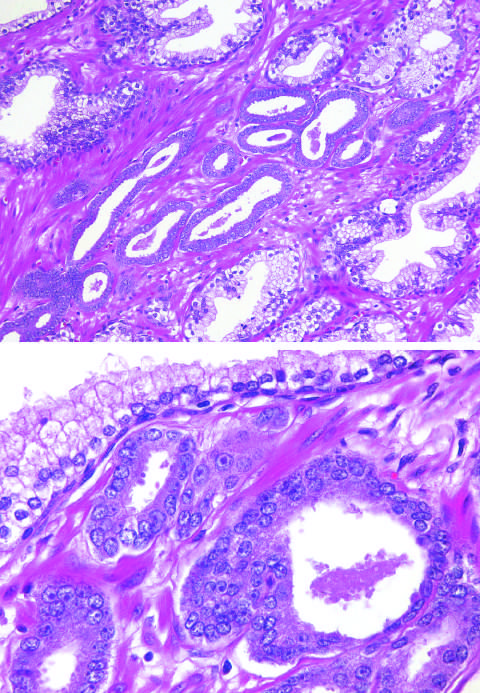does embolus derived from a lower-extremity deep venous thrombus show several small malignant glands with enlarged nuclei, prominent nucleoli, and dark cytoplasm, as compared with the larger, benign gland?
Answer the question using a single word or phrase. No 